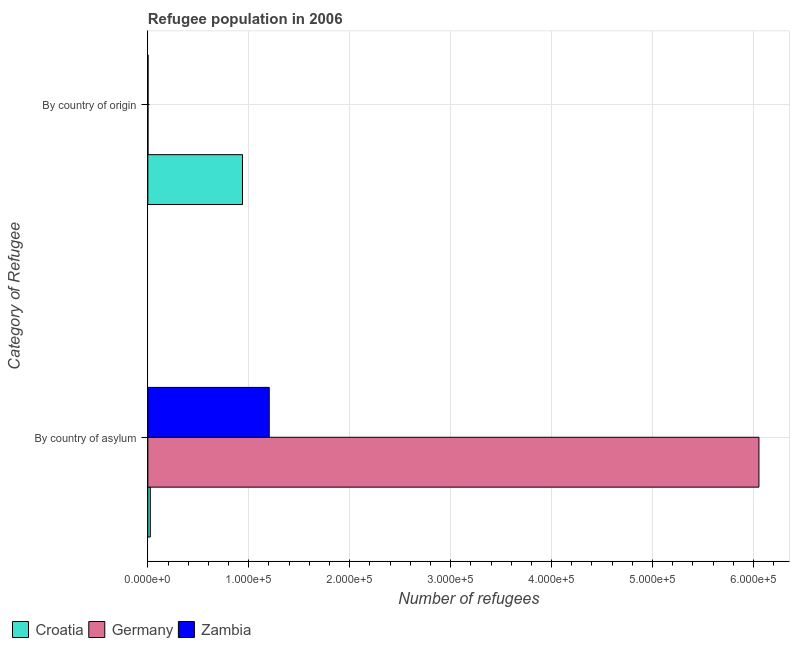How many different coloured bars are there?
Provide a succinct answer. 3. How many groups of bars are there?
Ensure brevity in your answer.  2. Are the number of bars on each tick of the Y-axis equal?
Keep it short and to the point. Yes. How many bars are there on the 1st tick from the top?
Give a very brief answer. 3. How many bars are there on the 1st tick from the bottom?
Keep it short and to the point. 3. What is the label of the 1st group of bars from the top?
Provide a short and direct response. By country of origin. What is the number of refugees by country of asylum in Germany?
Ensure brevity in your answer.  6.05e+05. Across all countries, what is the maximum number of refugees by country of origin?
Your response must be concise. 9.38e+04. Across all countries, what is the minimum number of refugees by country of asylum?
Your answer should be compact. 2443. In which country was the number of refugees by country of origin maximum?
Make the answer very short. Croatia. In which country was the number of refugees by country of origin minimum?
Your answer should be compact. Germany. What is the total number of refugees by country of asylum in the graph?
Provide a short and direct response. 7.28e+05. What is the difference between the number of refugees by country of origin in Zambia and that in Croatia?
Give a very brief answer. -9.36e+04. What is the difference between the number of refugees by country of asylum in Germany and the number of refugees by country of origin in Croatia?
Your answer should be compact. 5.12e+05. What is the average number of refugees by country of origin per country?
Your response must be concise. 3.14e+04. What is the difference between the number of refugees by country of asylum and number of refugees by country of origin in Zambia?
Your answer should be very brief. 1.20e+05. In how many countries, is the number of refugees by country of asylum greater than 200000 ?
Offer a terse response. 1. What is the ratio of the number of refugees by country of origin in Croatia to that in Germany?
Provide a succinct answer. 822.52. Is the number of refugees by country of asylum in Zambia less than that in Croatia?
Your answer should be compact. No. In how many countries, is the number of refugees by country of asylum greater than the average number of refugees by country of asylum taken over all countries?
Your response must be concise. 1. What does the 3rd bar from the top in By country of origin represents?
Provide a succinct answer. Croatia. What does the 3rd bar from the bottom in By country of origin represents?
Your answer should be very brief. Zambia. How many bars are there?
Your answer should be very brief. 6. Are all the bars in the graph horizontal?
Provide a succinct answer. Yes. How are the legend labels stacked?
Offer a very short reply. Horizontal. What is the title of the graph?
Make the answer very short. Refugee population in 2006. Does "Egypt, Arab Rep." appear as one of the legend labels in the graph?
Provide a succinct answer. No. What is the label or title of the X-axis?
Give a very brief answer. Number of refugees. What is the label or title of the Y-axis?
Provide a short and direct response. Category of Refugee. What is the Number of refugees in Croatia in By country of asylum?
Offer a very short reply. 2443. What is the Number of refugees in Germany in By country of asylum?
Provide a short and direct response. 6.05e+05. What is the Number of refugees in Zambia in By country of asylum?
Make the answer very short. 1.20e+05. What is the Number of refugees of Croatia in By country of origin?
Your answer should be very brief. 9.38e+04. What is the Number of refugees in Germany in By country of origin?
Offer a very short reply. 114. What is the Number of refugees of Zambia in By country of origin?
Ensure brevity in your answer.  203. Across all Category of Refugee, what is the maximum Number of refugees of Croatia?
Give a very brief answer. 9.38e+04. Across all Category of Refugee, what is the maximum Number of refugees in Germany?
Your response must be concise. 6.05e+05. Across all Category of Refugee, what is the maximum Number of refugees of Zambia?
Offer a very short reply. 1.20e+05. Across all Category of Refugee, what is the minimum Number of refugees in Croatia?
Your answer should be very brief. 2443. Across all Category of Refugee, what is the minimum Number of refugees in Germany?
Give a very brief answer. 114. Across all Category of Refugee, what is the minimum Number of refugees in Zambia?
Ensure brevity in your answer.  203. What is the total Number of refugees of Croatia in the graph?
Your answer should be compact. 9.62e+04. What is the total Number of refugees in Germany in the graph?
Your answer should be compact. 6.06e+05. What is the total Number of refugees of Zambia in the graph?
Your answer should be compact. 1.20e+05. What is the difference between the Number of refugees of Croatia in By country of asylum and that in By country of origin?
Offer a terse response. -9.13e+04. What is the difference between the Number of refugees of Germany in By country of asylum and that in By country of origin?
Your answer should be compact. 6.05e+05. What is the difference between the Number of refugees of Zambia in By country of asylum and that in By country of origin?
Keep it short and to the point. 1.20e+05. What is the difference between the Number of refugees in Croatia in By country of asylum and the Number of refugees in Germany in By country of origin?
Keep it short and to the point. 2329. What is the difference between the Number of refugees of Croatia in By country of asylum and the Number of refugees of Zambia in By country of origin?
Offer a very short reply. 2240. What is the difference between the Number of refugees of Germany in By country of asylum and the Number of refugees of Zambia in By country of origin?
Your response must be concise. 6.05e+05. What is the average Number of refugees of Croatia per Category of Refugee?
Provide a short and direct response. 4.81e+04. What is the average Number of refugees of Germany per Category of Refugee?
Provide a short and direct response. 3.03e+05. What is the average Number of refugees of Zambia per Category of Refugee?
Provide a short and direct response. 6.02e+04. What is the difference between the Number of refugees of Croatia and Number of refugees of Germany in By country of asylum?
Make the answer very short. -6.03e+05. What is the difference between the Number of refugees of Croatia and Number of refugees of Zambia in By country of asylum?
Offer a terse response. -1.18e+05. What is the difference between the Number of refugees of Germany and Number of refugees of Zambia in By country of asylum?
Ensure brevity in your answer.  4.85e+05. What is the difference between the Number of refugees in Croatia and Number of refugees in Germany in By country of origin?
Your answer should be very brief. 9.37e+04. What is the difference between the Number of refugees of Croatia and Number of refugees of Zambia in By country of origin?
Your response must be concise. 9.36e+04. What is the difference between the Number of refugees in Germany and Number of refugees in Zambia in By country of origin?
Ensure brevity in your answer.  -89. What is the ratio of the Number of refugees in Croatia in By country of asylum to that in By country of origin?
Your response must be concise. 0.03. What is the ratio of the Number of refugees in Germany in By country of asylum to that in By country of origin?
Give a very brief answer. 5310.58. What is the ratio of the Number of refugees of Zambia in By country of asylum to that in By country of origin?
Provide a short and direct response. 592.38. What is the difference between the highest and the second highest Number of refugees of Croatia?
Your response must be concise. 9.13e+04. What is the difference between the highest and the second highest Number of refugees in Germany?
Your answer should be very brief. 6.05e+05. What is the difference between the highest and the second highest Number of refugees in Zambia?
Offer a very short reply. 1.20e+05. What is the difference between the highest and the lowest Number of refugees in Croatia?
Make the answer very short. 9.13e+04. What is the difference between the highest and the lowest Number of refugees of Germany?
Ensure brevity in your answer.  6.05e+05. What is the difference between the highest and the lowest Number of refugees of Zambia?
Ensure brevity in your answer.  1.20e+05. 